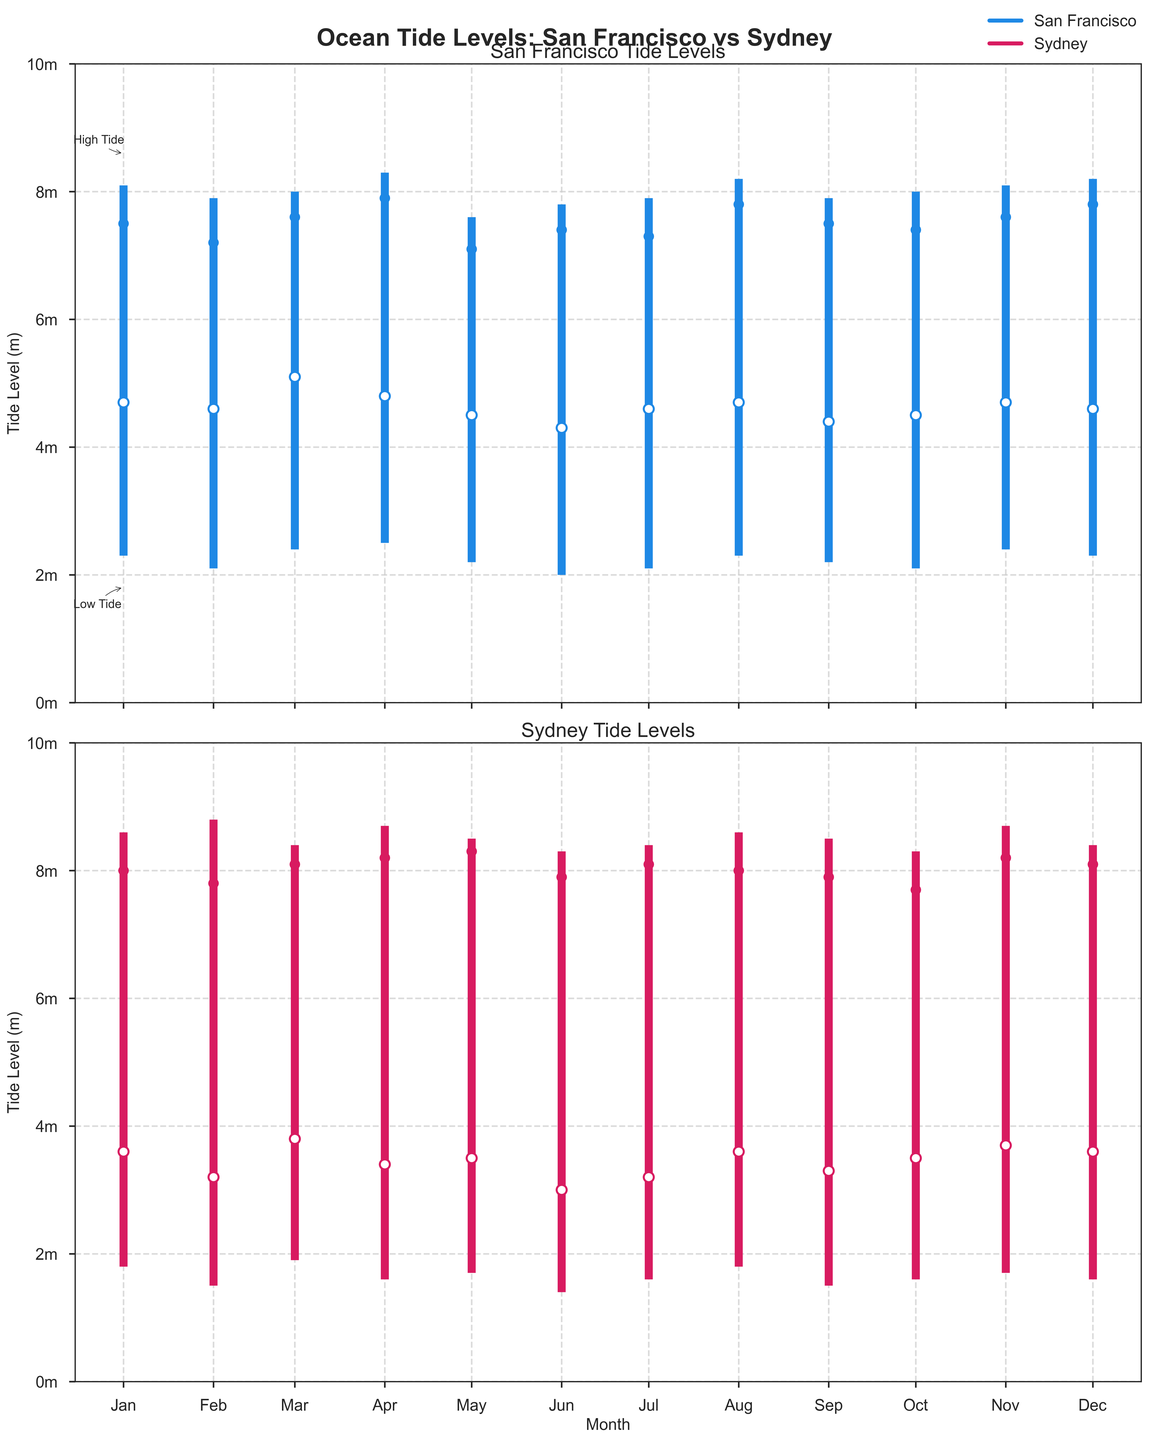What are the highest and lowest tide levels in San Francisco in January? The plot shows separate lines for the high and low tide levels. In San Francisco in January, the high tide is at 8.1 meters, and the low tide is at 2.3 meters.
Answer: High Tide: 8.1m, Low Tide: 2.3m What is the opening tide level in Sydney in June? The "opening tide" is marked by a white circle. For Sydney in June, this can be identified by observing the position of the white circle, which is at 3.0 meters according to the figure.
Answer: 3.0m Which month has the highest closing tide in San Francisco? Closing tides are marked with a filled circle. In the plot, find the highest position of the filled circle through the months for San Francisco, which is in April and the tide is 7.9 meters.
Answer: April In which month does Sydney experience the lowest low tide level? The lowest low tide can be identified by the position of the lowest point on the candlesticks for Sydney. This occurs in June at 1.4 meters.
Answer: June What is the average opening tide level for San Francisco from January to June? To compute the average, sum the opening tide levels from January to June, i.e., 4.7 + 4.6 + 5.1 + 4.8 + 4.5 + 4.3 = 28. Then divide by 6.
Answer: (4.7 + 4.6 + 5.1 + 4.8 + 4.5 + 4.3) / 6 = 4.67m How does the range between high and low tides in Sydney in March compare to that in November? The range is the difference between the high and low tide levels. In March, the range is 8.4 - 1.9 = 6.5 meters. In November, the range is 8.7 - 1.7 = 7.0 meters. Comparing these, November's range is greater.
Answer: November has a higher range Which location generally has a more significant variation between high and low tides throughout the year? To determine this, compare the high-low range for each month at both locations. Sydney typically shows larger ranges in tide levels compared to San Francisco.
Answer: Sydney What is the difference in closing tide levels between San Francisco and Sydney in October? Examine the filled circles for October in both the San Francisco and Sydney plots. San Francisco's closing tide is 7.4 meters and Sydney's is 7.7 meters. The difference is 7.7 - 7.4 = 0.3 meters.
Answer: 0.3m During which months does San Francisco experience a high tide level above 8 meters? Identify the months where the top of the candlestick exceeds the 8-meter marker in San Francisco. These months are January, March, April, August, November, and December.
Answer: January, March, April, August, November, December 